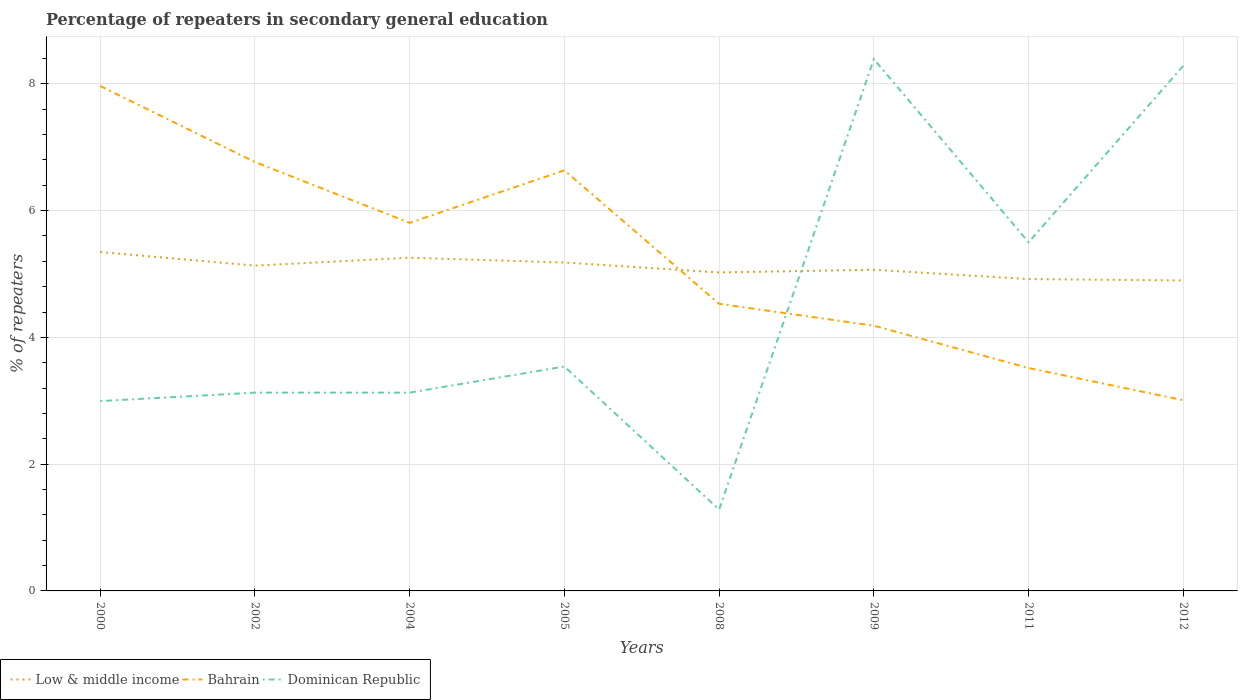Does the line corresponding to Dominican Republic intersect with the line corresponding to Low & middle income?
Offer a terse response. Yes. Across all years, what is the maximum percentage of repeaters in secondary general education in Dominican Republic?
Your answer should be compact. 1.28. In which year was the percentage of repeaters in secondary general education in Dominican Republic maximum?
Ensure brevity in your answer.  2008. What is the total percentage of repeaters in secondary general education in Low & middle income in the graph?
Your answer should be very brief. 0.21. What is the difference between the highest and the second highest percentage of repeaters in secondary general education in Dominican Republic?
Provide a short and direct response. 7.11. How many lines are there?
Make the answer very short. 3. How many years are there in the graph?
Provide a succinct answer. 8. What is the difference between two consecutive major ticks on the Y-axis?
Offer a very short reply. 2. Does the graph contain any zero values?
Offer a very short reply. No. Where does the legend appear in the graph?
Offer a very short reply. Bottom left. How many legend labels are there?
Your answer should be very brief. 3. How are the legend labels stacked?
Offer a terse response. Horizontal. What is the title of the graph?
Offer a very short reply. Percentage of repeaters in secondary general education. Does "Bolivia" appear as one of the legend labels in the graph?
Ensure brevity in your answer.  No. What is the label or title of the Y-axis?
Make the answer very short. % of repeaters. What is the % of repeaters of Low & middle income in 2000?
Offer a terse response. 5.35. What is the % of repeaters in Bahrain in 2000?
Your response must be concise. 7.97. What is the % of repeaters in Dominican Republic in 2000?
Offer a very short reply. 2.99. What is the % of repeaters of Low & middle income in 2002?
Ensure brevity in your answer.  5.13. What is the % of repeaters of Bahrain in 2002?
Offer a very short reply. 6.77. What is the % of repeaters of Dominican Republic in 2002?
Keep it short and to the point. 3.13. What is the % of repeaters of Low & middle income in 2004?
Ensure brevity in your answer.  5.26. What is the % of repeaters in Bahrain in 2004?
Keep it short and to the point. 5.81. What is the % of repeaters of Dominican Republic in 2004?
Offer a terse response. 3.13. What is the % of repeaters of Low & middle income in 2005?
Your answer should be compact. 5.18. What is the % of repeaters of Bahrain in 2005?
Your answer should be very brief. 6.64. What is the % of repeaters in Dominican Republic in 2005?
Ensure brevity in your answer.  3.54. What is the % of repeaters of Low & middle income in 2008?
Your response must be concise. 5.02. What is the % of repeaters in Bahrain in 2008?
Give a very brief answer. 4.53. What is the % of repeaters of Dominican Republic in 2008?
Offer a terse response. 1.28. What is the % of repeaters of Low & middle income in 2009?
Ensure brevity in your answer.  5.07. What is the % of repeaters in Bahrain in 2009?
Make the answer very short. 4.18. What is the % of repeaters of Dominican Republic in 2009?
Offer a terse response. 8.39. What is the % of repeaters of Low & middle income in 2011?
Offer a very short reply. 4.92. What is the % of repeaters in Bahrain in 2011?
Keep it short and to the point. 3.52. What is the % of repeaters of Dominican Republic in 2011?
Make the answer very short. 5.5. What is the % of repeaters in Low & middle income in 2012?
Make the answer very short. 4.9. What is the % of repeaters of Bahrain in 2012?
Your answer should be compact. 3.01. What is the % of repeaters in Dominican Republic in 2012?
Your response must be concise. 8.29. Across all years, what is the maximum % of repeaters of Low & middle income?
Keep it short and to the point. 5.35. Across all years, what is the maximum % of repeaters in Bahrain?
Provide a succinct answer. 7.97. Across all years, what is the maximum % of repeaters in Dominican Republic?
Provide a succinct answer. 8.39. Across all years, what is the minimum % of repeaters of Low & middle income?
Your answer should be very brief. 4.9. Across all years, what is the minimum % of repeaters of Bahrain?
Keep it short and to the point. 3.01. Across all years, what is the minimum % of repeaters of Dominican Republic?
Ensure brevity in your answer.  1.28. What is the total % of repeaters in Low & middle income in the graph?
Offer a terse response. 40.83. What is the total % of repeaters of Bahrain in the graph?
Keep it short and to the point. 42.42. What is the total % of repeaters in Dominican Republic in the graph?
Provide a succinct answer. 36.25. What is the difference between the % of repeaters of Low & middle income in 2000 and that in 2002?
Your answer should be compact. 0.21. What is the difference between the % of repeaters in Bahrain in 2000 and that in 2002?
Offer a very short reply. 1.2. What is the difference between the % of repeaters in Dominican Republic in 2000 and that in 2002?
Your answer should be compact. -0.13. What is the difference between the % of repeaters of Low & middle income in 2000 and that in 2004?
Make the answer very short. 0.09. What is the difference between the % of repeaters in Bahrain in 2000 and that in 2004?
Provide a succinct answer. 2.16. What is the difference between the % of repeaters in Dominican Republic in 2000 and that in 2004?
Keep it short and to the point. -0.13. What is the difference between the % of repeaters of Low & middle income in 2000 and that in 2005?
Your response must be concise. 0.17. What is the difference between the % of repeaters in Bahrain in 2000 and that in 2005?
Keep it short and to the point. 1.33. What is the difference between the % of repeaters in Dominican Republic in 2000 and that in 2005?
Offer a terse response. -0.55. What is the difference between the % of repeaters in Low & middle income in 2000 and that in 2008?
Your answer should be compact. 0.32. What is the difference between the % of repeaters of Bahrain in 2000 and that in 2008?
Your answer should be compact. 3.44. What is the difference between the % of repeaters in Dominican Republic in 2000 and that in 2008?
Offer a terse response. 1.71. What is the difference between the % of repeaters in Low & middle income in 2000 and that in 2009?
Your answer should be compact. 0.28. What is the difference between the % of repeaters in Bahrain in 2000 and that in 2009?
Your answer should be compact. 3.78. What is the difference between the % of repeaters in Dominican Republic in 2000 and that in 2009?
Give a very brief answer. -5.4. What is the difference between the % of repeaters of Low & middle income in 2000 and that in 2011?
Provide a succinct answer. 0.43. What is the difference between the % of repeaters in Bahrain in 2000 and that in 2011?
Give a very brief answer. 4.45. What is the difference between the % of repeaters in Dominican Republic in 2000 and that in 2011?
Your answer should be very brief. -2.51. What is the difference between the % of repeaters of Low & middle income in 2000 and that in 2012?
Keep it short and to the point. 0.45. What is the difference between the % of repeaters in Bahrain in 2000 and that in 2012?
Keep it short and to the point. 4.96. What is the difference between the % of repeaters of Dominican Republic in 2000 and that in 2012?
Make the answer very short. -5.29. What is the difference between the % of repeaters of Low & middle income in 2002 and that in 2004?
Offer a terse response. -0.12. What is the difference between the % of repeaters in Bahrain in 2002 and that in 2004?
Make the answer very short. 0.96. What is the difference between the % of repeaters in Low & middle income in 2002 and that in 2005?
Offer a terse response. -0.05. What is the difference between the % of repeaters of Bahrain in 2002 and that in 2005?
Your answer should be compact. 0.13. What is the difference between the % of repeaters of Dominican Republic in 2002 and that in 2005?
Provide a short and direct response. -0.41. What is the difference between the % of repeaters in Low & middle income in 2002 and that in 2008?
Your answer should be compact. 0.11. What is the difference between the % of repeaters of Bahrain in 2002 and that in 2008?
Offer a very short reply. 2.24. What is the difference between the % of repeaters of Dominican Republic in 2002 and that in 2008?
Provide a short and direct response. 1.85. What is the difference between the % of repeaters in Low & middle income in 2002 and that in 2009?
Your answer should be compact. 0.07. What is the difference between the % of repeaters of Bahrain in 2002 and that in 2009?
Give a very brief answer. 2.58. What is the difference between the % of repeaters of Dominican Republic in 2002 and that in 2009?
Give a very brief answer. -5.26. What is the difference between the % of repeaters in Low & middle income in 2002 and that in 2011?
Make the answer very short. 0.21. What is the difference between the % of repeaters of Dominican Republic in 2002 and that in 2011?
Your answer should be compact. -2.37. What is the difference between the % of repeaters of Low & middle income in 2002 and that in 2012?
Your answer should be very brief. 0.23. What is the difference between the % of repeaters in Bahrain in 2002 and that in 2012?
Offer a terse response. 3.76. What is the difference between the % of repeaters in Dominican Republic in 2002 and that in 2012?
Offer a very short reply. -5.16. What is the difference between the % of repeaters in Low & middle income in 2004 and that in 2005?
Offer a very short reply. 0.08. What is the difference between the % of repeaters in Bahrain in 2004 and that in 2005?
Your answer should be very brief. -0.83. What is the difference between the % of repeaters in Dominican Republic in 2004 and that in 2005?
Keep it short and to the point. -0.41. What is the difference between the % of repeaters in Low & middle income in 2004 and that in 2008?
Your answer should be very brief. 0.23. What is the difference between the % of repeaters of Bahrain in 2004 and that in 2008?
Your response must be concise. 1.28. What is the difference between the % of repeaters of Dominican Republic in 2004 and that in 2008?
Make the answer very short. 1.85. What is the difference between the % of repeaters in Low & middle income in 2004 and that in 2009?
Provide a short and direct response. 0.19. What is the difference between the % of repeaters in Bahrain in 2004 and that in 2009?
Ensure brevity in your answer.  1.62. What is the difference between the % of repeaters in Dominican Republic in 2004 and that in 2009?
Your answer should be very brief. -5.26. What is the difference between the % of repeaters of Low & middle income in 2004 and that in 2011?
Your answer should be very brief. 0.34. What is the difference between the % of repeaters in Bahrain in 2004 and that in 2011?
Make the answer very short. 2.29. What is the difference between the % of repeaters of Dominican Republic in 2004 and that in 2011?
Keep it short and to the point. -2.37. What is the difference between the % of repeaters in Low & middle income in 2004 and that in 2012?
Give a very brief answer. 0.36. What is the difference between the % of repeaters in Bahrain in 2004 and that in 2012?
Give a very brief answer. 2.8. What is the difference between the % of repeaters in Dominican Republic in 2004 and that in 2012?
Your response must be concise. -5.16. What is the difference between the % of repeaters of Low & middle income in 2005 and that in 2008?
Ensure brevity in your answer.  0.16. What is the difference between the % of repeaters in Bahrain in 2005 and that in 2008?
Your answer should be compact. 2.11. What is the difference between the % of repeaters in Dominican Republic in 2005 and that in 2008?
Provide a succinct answer. 2.26. What is the difference between the % of repeaters in Low & middle income in 2005 and that in 2009?
Your answer should be compact. 0.11. What is the difference between the % of repeaters of Bahrain in 2005 and that in 2009?
Provide a short and direct response. 2.45. What is the difference between the % of repeaters of Dominican Republic in 2005 and that in 2009?
Give a very brief answer. -4.85. What is the difference between the % of repeaters in Low & middle income in 2005 and that in 2011?
Provide a short and direct response. 0.26. What is the difference between the % of repeaters in Bahrain in 2005 and that in 2011?
Make the answer very short. 3.12. What is the difference between the % of repeaters of Dominican Republic in 2005 and that in 2011?
Your answer should be compact. -1.96. What is the difference between the % of repeaters in Low & middle income in 2005 and that in 2012?
Provide a succinct answer. 0.28. What is the difference between the % of repeaters of Bahrain in 2005 and that in 2012?
Keep it short and to the point. 3.63. What is the difference between the % of repeaters of Dominican Republic in 2005 and that in 2012?
Give a very brief answer. -4.75. What is the difference between the % of repeaters of Low & middle income in 2008 and that in 2009?
Your answer should be very brief. -0.04. What is the difference between the % of repeaters of Bahrain in 2008 and that in 2009?
Your response must be concise. 0.35. What is the difference between the % of repeaters of Dominican Republic in 2008 and that in 2009?
Your response must be concise. -7.11. What is the difference between the % of repeaters of Low & middle income in 2008 and that in 2011?
Offer a very short reply. 0.11. What is the difference between the % of repeaters in Bahrain in 2008 and that in 2011?
Provide a short and direct response. 1.01. What is the difference between the % of repeaters of Dominican Republic in 2008 and that in 2011?
Provide a short and direct response. -4.22. What is the difference between the % of repeaters of Low & middle income in 2008 and that in 2012?
Your answer should be compact. 0.13. What is the difference between the % of repeaters in Bahrain in 2008 and that in 2012?
Provide a short and direct response. 1.52. What is the difference between the % of repeaters in Dominican Republic in 2008 and that in 2012?
Offer a very short reply. -7. What is the difference between the % of repeaters of Low & middle income in 2009 and that in 2011?
Provide a succinct answer. 0.15. What is the difference between the % of repeaters in Bahrain in 2009 and that in 2011?
Give a very brief answer. 0.67. What is the difference between the % of repeaters of Dominican Republic in 2009 and that in 2011?
Keep it short and to the point. 2.89. What is the difference between the % of repeaters of Low & middle income in 2009 and that in 2012?
Provide a short and direct response. 0.17. What is the difference between the % of repeaters in Bahrain in 2009 and that in 2012?
Provide a succinct answer. 1.18. What is the difference between the % of repeaters of Dominican Republic in 2009 and that in 2012?
Offer a very short reply. 0.1. What is the difference between the % of repeaters in Low & middle income in 2011 and that in 2012?
Provide a succinct answer. 0.02. What is the difference between the % of repeaters of Bahrain in 2011 and that in 2012?
Your response must be concise. 0.51. What is the difference between the % of repeaters in Dominican Republic in 2011 and that in 2012?
Your response must be concise. -2.79. What is the difference between the % of repeaters in Low & middle income in 2000 and the % of repeaters in Bahrain in 2002?
Provide a succinct answer. -1.42. What is the difference between the % of repeaters in Low & middle income in 2000 and the % of repeaters in Dominican Republic in 2002?
Keep it short and to the point. 2.22. What is the difference between the % of repeaters in Bahrain in 2000 and the % of repeaters in Dominican Republic in 2002?
Give a very brief answer. 4.84. What is the difference between the % of repeaters in Low & middle income in 2000 and the % of repeaters in Bahrain in 2004?
Keep it short and to the point. -0.46. What is the difference between the % of repeaters of Low & middle income in 2000 and the % of repeaters of Dominican Republic in 2004?
Your answer should be very brief. 2.22. What is the difference between the % of repeaters of Bahrain in 2000 and the % of repeaters of Dominican Republic in 2004?
Provide a succinct answer. 4.84. What is the difference between the % of repeaters in Low & middle income in 2000 and the % of repeaters in Bahrain in 2005?
Ensure brevity in your answer.  -1.29. What is the difference between the % of repeaters of Low & middle income in 2000 and the % of repeaters of Dominican Republic in 2005?
Provide a short and direct response. 1.81. What is the difference between the % of repeaters in Bahrain in 2000 and the % of repeaters in Dominican Republic in 2005?
Your answer should be very brief. 4.43. What is the difference between the % of repeaters of Low & middle income in 2000 and the % of repeaters of Bahrain in 2008?
Your answer should be very brief. 0.82. What is the difference between the % of repeaters of Low & middle income in 2000 and the % of repeaters of Dominican Republic in 2008?
Ensure brevity in your answer.  4.06. What is the difference between the % of repeaters of Bahrain in 2000 and the % of repeaters of Dominican Republic in 2008?
Provide a succinct answer. 6.68. What is the difference between the % of repeaters of Low & middle income in 2000 and the % of repeaters of Bahrain in 2009?
Offer a very short reply. 1.16. What is the difference between the % of repeaters in Low & middle income in 2000 and the % of repeaters in Dominican Republic in 2009?
Your answer should be very brief. -3.04. What is the difference between the % of repeaters of Bahrain in 2000 and the % of repeaters of Dominican Republic in 2009?
Your response must be concise. -0.42. What is the difference between the % of repeaters in Low & middle income in 2000 and the % of repeaters in Bahrain in 2011?
Your response must be concise. 1.83. What is the difference between the % of repeaters in Low & middle income in 2000 and the % of repeaters in Dominican Republic in 2011?
Your response must be concise. -0.15. What is the difference between the % of repeaters in Bahrain in 2000 and the % of repeaters in Dominican Republic in 2011?
Your response must be concise. 2.47. What is the difference between the % of repeaters in Low & middle income in 2000 and the % of repeaters in Bahrain in 2012?
Make the answer very short. 2.34. What is the difference between the % of repeaters in Low & middle income in 2000 and the % of repeaters in Dominican Republic in 2012?
Offer a very short reply. -2.94. What is the difference between the % of repeaters in Bahrain in 2000 and the % of repeaters in Dominican Republic in 2012?
Give a very brief answer. -0.32. What is the difference between the % of repeaters in Low & middle income in 2002 and the % of repeaters in Bahrain in 2004?
Make the answer very short. -0.67. What is the difference between the % of repeaters of Low & middle income in 2002 and the % of repeaters of Dominican Republic in 2004?
Ensure brevity in your answer.  2. What is the difference between the % of repeaters of Bahrain in 2002 and the % of repeaters of Dominican Republic in 2004?
Make the answer very short. 3.64. What is the difference between the % of repeaters in Low & middle income in 2002 and the % of repeaters in Bahrain in 2005?
Provide a short and direct response. -1.5. What is the difference between the % of repeaters of Low & middle income in 2002 and the % of repeaters of Dominican Republic in 2005?
Keep it short and to the point. 1.59. What is the difference between the % of repeaters in Bahrain in 2002 and the % of repeaters in Dominican Republic in 2005?
Make the answer very short. 3.23. What is the difference between the % of repeaters in Low & middle income in 2002 and the % of repeaters in Bahrain in 2008?
Your answer should be very brief. 0.6. What is the difference between the % of repeaters of Low & middle income in 2002 and the % of repeaters of Dominican Republic in 2008?
Your answer should be very brief. 3.85. What is the difference between the % of repeaters of Bahrain in 2002 and the % of repeaters of Dominican Republic in 2008?
Your response must be concise. 5.48. What is the difference between the % of repeaters in Low & middle income in 2002 and the % of repeaters in Bahrain in 2009?
Ensure brevity in your answer.  0.95. What is the difference between the % of repeaters in Low & middle income in 2002 and the % of repeaters in Dominican Republic in 2009?
Give a very brief answer. -3.26. What is the difference between the % of repeaters in Bahrain in 2002 and the % of repeaters in Dominican Republic in 2009?
Your answer should be very brief. -1.62. What is the difference between the % of repeaters of Low & middle income in 2002 and the % of repeaters of Bahrain in 2011?
Your answer should be very brief. 1.62. What is the difference between the % of repeaters of Low & middle income in 2002 and the % of repeaters of Dominican Republic in 2011?
Offer a very short reply. -0.37. What is the difference between the % of repeaters in Bahrain in 2002 and the % of repeaters in Dominican Republic in 2011?
Provide a short and direct response. 1.27. What is the difference between the % of repeaters of Low & middle income in 2002 and the % of repeaters of Bahrain in 2012?
Your answer should be very brief. 2.12. What is the difference between the % of repeaters of Low & middle income in 2002 and the % of repeaters of Dominican Republic in 2012?
Your answer should be very brief. -3.15. What is the difference between the % of repeaters in Bahrain in 2002 and the % of repeaters in Dominican Republic in 2012?
Your answer should be very brief. -1.52. What is the difference between the % of repeaters of Low & middle income in 2004 and the % of repeaters of Bahrain in 2005?
Make the answer very short. -1.38. What is the difference between the % of repeaters in Low & middle income in 2004 and the % of repeaters in Dominican Republic in 2005?
Your answer should be very brief. 1.72. What is the difference between the % of repeaters in Bahrain in 2004 and the % of repeaters in Dominican Republic in 2005?
Your answer should be very brief. 2.27. What is the difference between the % of repeaters of Low & middle income in 2004 and the % of repeaters of Bahrain in 2008?
Give a very brief answer. 0.73. What is the difference between the % of repeaters in Low & middle income in 2004 and the % of repeaters in Dominican Republic in 2008?
Your answer should be very brief. 3.97. What is the difference between the % of repeaters of Bahrain in 2004 and the % of repeaters of Dominican Republic in 2008?
Provide a short and direct response. 4.52. What is the difference between the % of repeaters of Low & middle income in 2004 and the % of repeaters of Bahrain in 2009?
Offer a terse response. 1.07. What is the difference between the % of repeaters of Low & middle income in 2004 and the % of repeaters of Dominican Republic in 2009?
Your answer should be compact. -3.13. What is the difference between the % of repeaters in Bahrain in 2004 and the % of repeaters in Dominican Republic in 2009?
Your answer should be compact. -2.58. What is the difference between the % of repeaters in Low & middle income in 2004 and the % of repeaters in Bahrain in 2011?
Offer a very short reply. 1.74. What is the difference between the % of repeaters of Low & middle income in 2004 and the % of repeaters of Dominican Republic in 2011?
Keep it short and to the point. -0.24. What is the difference between the % of repeaters of Bahrain in 2004 and the % of repeaters of Dominican Republic in 2011?
Keep it short and to the point. 0.31. What is the difference between the % of repeaters in Low & middle income in 2004 and the % of repeaters in Bahrain in 2012?
Offer a very short reply. 2.25. What is the difference between the % of repeaters of Low & middle income in 2004 and the % of repeaters of Dominican Republic in 2012?
Your response must be concise. -3.03. What is the difference between the % of repeaters of Bahrain in 2004 and the % of repeaters of Dominican Republic in 2012?
Make the answer very short. -2.48. What is the difference between the % of repeaters in Low & middle income in 2005 and the % of repeaters in Bahrain in 2008?
Provide a short and direct response. 0.65. What is the difference between the % of repeaters of Low & middle income in 2005 and the % of repeaters of Dominican Republic in 2008?
Provide a short and direct response. 3.9. What is the difference between the % of repeaters of Bahrain in 2005 and the % of repeaters of Dominican Republic in 2008?
Offer a very short reply. 5.35. What is the difference between the % of repeaters of Low & middle income in 2005 and the % of repeaters of Bahrain in 2009?
Ensure brevity in your answer.  1. What is the difference between the % of repeaters of Low & middle income in 2005 and the % of repeaters of Dominican Republic in 2009?
Give a very brief answer. -3.21. What is the difference between the % of repeaters of Bahrain in 2005 and the % of repeaters of Dominican Republic in 2009?
Your response must be concise. -1.75. What is the difference between the % of repeaters of Low & middle income in 2005 and the % of repeaters of Bahrain in 2011?
Give a very brief answer. 1.66. What is the difference between the % of repeaters of Low & middle income in 2005 and the % of repeaters of Dominican Republic in 2011?
Ensure brevity in your answer.  -0.32. What is the difference between the % of repeaters in Bahrain in 2005 and the % of repeaters in Dominican Republic in 2011?
Provide a short and direct response. 1.14. What is the difference between the % of repeaters of Low & middle income in 2005 and the % of repeaters of Bahrain in 2012?
Offer a terse response. 2.17. What is the difference between the % of repeaters of Low & middle income in 2005 and the % of repeaters of Dominican Republic in 2012?
Offer a very short reply. -3.1. What is the difference between the % of repeaters of Bahrain in 2005 and the % of repeaters of Dominican Republic in 2012?
Offer a very short reply. -1.65. What is the difference between the % of repeaters in Low & middle income in 2008 and the % of repeaters in Bahrain in 2009?
Make the answer very short. 0.84. What is the difference between the % of repeaters of Low & middle income in 2008 and the % of repeaters of Dominican Republic in 2009?
Offer a terse response. -3.37. What is the difference between the % of repeaters in Bahrain in 2008 and the % of repeaters in Dominican Republic in 2009?
Give a very brief answer. -3.86. What is the difference between the % of repeaters of Low & middle income in 2008 and the % of repeaters of Bahrain in 2011?
Give a very brief answer. 1.51. What is the difference between the % of repeaters of Low & middle income in 2008 and the % of repeaters of Dominican Republic in 2011?
Give a very brief answer. -0.48. What is the difference between the % of repeaters of Bahrain in 2008 and the % of repeaters of Dominican Republic in 2011?
Your answer should be very brief. -0.97. What is the difference between the % of repeaters in Low & middle income in 2008 and the % of repeaters in Bahrain in 2012?
Your answer should be compact. 2.02. What is the difference between the % of repeaters of Low & middle income in 2008 and the % of repeaters of Dominican Republic in 2012?
Give a very brief answer. -3.26. What is the difference between the % of repeaters of Bahrain in 2008 and the % of repeaters of Dominican Republic in 2012?
Provide a short and direct response. -3.76. What is the difference between the % of repeaters in Low & middle income in 2009 and the % of repeaters in Bahrain in 2011?
Give a very brief answer. 1.55. What is the difference between the % of repeaters in Low & middle income in 2009 and the % of repeaters in Dominican Republic in 2011?
Your response must be concise. -0.43. What is the difference between the % of repeaters in Bahrain in 2009 and the % of repeaters in Dominican Republic in 2011?
Make the answer very short. -1.32. What is the difference between the % of repeaters of Low & middle income in 2009 and the % of repeaters of Bahrain in 2012?
Make the answer very short. 2.06. What is the difference between the % of repeaters in Low & middle income in 2009 and the % of repeaters in Dominican Republic in 2012?
Keep it short and to the point. -3.22. What is the difference between the % of repeaters in Bahrain in 2009 and the % of repeaters in Dominican Republic in 2012?
Your answer should be very brief. -4.1. What is the difference between the % of repeaters in Low & middle income in 2011 and the % of repeaters in Bahrain in 2012?
Give a very brief answer. 1.91. What is the difference between the % of repeaters in Low & middle income in 2011 and the % of repeaters in Dominican Republic in 2012?
Give a very brief answer. -3.37. What is the difference between the % of repeaters of Bahrain in 2011 and the % of repeaters of Dominican Republic in 2012?
Your answer should be compact. -4.77. What is the average % of repeaters in Low & middle income per year?
Ensure brevity in your answer.  5.1. What is the average % of repeaters of Bahrain per year?
Keep it short and to the point. 5.3. What is the average % of repeaters in Dominican Republic per year?
Offer a terse response. 4.53. In the year 2000, what is the difference between the % of repeaters of Low & middle income and % of repeaters of Bahrain?
Offer a very short reply. -2.62. In the year 2000, what is the difference between the % of repeaters in Low & middle income and % of repeaters in Dominican Republic?
Offer a very short reply. 2.35. In the year 2000, what is the difference between the % of repeaters in Bahrain and % of repeaters in Dominican Republic?
Provide a succinct answer. 4.97. In the year 2002, what is the difference between the % of repeaters in Low & middle income and % of repeaters in Bahrain?
Ensure brevity in your answer.  -1.63. In the year 2002, what is the difference between the % of repeaters of Low & middle income and % of repeaters of Dominican Republic?
Your answer should be compact. 2. In the year 2002, what is the difference between the % of repeaters in Bahrain and % of repeaters in Dominican Republic?
Offer a terse response. 3.64. In the year 2004, what is the difference between the % of repeaters in Low & middle income and % of repeaters in Bahrain?
Offer a very short reply. -0.55. In the year 2004, what is the difference between the % of repeaters in Low & middle income and % of repeaters in Dominican Republic?
Give a very brief answer. 2.13. In the year 2004, what is the difference between the % of repeaters in Bahrain and % of repeaters in Dominican Republic?
Offer a very short reply. 2.68. In the year 2005, what is the difference between the % of repeaters in Low & middle income and % of repeaters in Bahrain?
Ensure brevity in your answer.  -1.45. In the year 2005, what is the difference between the % of repeaters of Low & middle income and % of repeaters of Dominican Republic?
Provide a short and direct response. 1.64. In the year 2005, what is the difference between the % of repeaters of Bahrain and % of repeaters of Dominican Republic?
Make the answer very short. 3.1. In the year 2008, what is the difference between the % of repeaters in Low & middle income and % of repeaters in Bahrain?
Make the answer very short. 0.49. In the year 2008, what is the difference between the % of repeaters of Low & middle income and % of repeaters of Dominican Republic?
Provide a succinct answer. 3.74. In the year 2008, what is the difference between the % of repeaters in Bahrain and % of repeaters in Dominican Republic?
Your answer should be compact. 3.25. In the year 2009, what is the difference between the % of repeaters in Low & middle income and % of repeaters in Bahrain?
Your answer should be compact. 0.88. In the year 2009, what is the difference between the % of repeaters in Low & middle income and % of repeaters in Dominican Republic?
Give a very brief answer. -3.32. In the year 2009, what is the difference between the % of repeaters in Bahrain and % of repeaters in Dominican Republic?
Provide a short and direct response. -4.21. In the year 2011, what is the difference between the % of repeaters in Low & middle income and % of repeaters in Bahrain?
Give a very brief answer. 1.4. In the year 2011, what is the difference between the % of repeaters of Low & middle income and % of repeaters of Dominican Republic?
Keep it short and to the point. -0.58. In the year 2011, what is the difference between the % of repeaters in Bahrain and % of repeaters in Dominican Republic?
Provide a short and direct response. -1.98. In the year 2012, what is the difference between the % of repeaters of Low & middle income and % of repeaters of Bahrain?
Provide a succinct answer. 1.89. In the year 2012, what is the difference between the % of repeaters in Low & middle income and % of repeaters in Dominican Republic?
Your answer should be very brief. -3.39. In the year 2012, what is the difference between the % of repeaters of Bahrain and % of repeaters of Dominican Republic?
Offer a very short reply. -5.28. What is the ratio of the % of repeaters in Low & middle income in 2000 to that in 2002?
Provide a short and direct response. 1.04. What is the ratio of the % of repeaters in Bahrain in 2000 to that in 2002?
Make the answer very short. 1.18. What is the ratio of the % of repeaters of Dominican Republic in 2000 to that in 2002?
Ensure brevity in your answer.  0.96. What is the ratio of the % of repeaters in Low & middle income in 2000 to that in 2004?
Offer a very short reply. 1.02. What is the ratio of the % of repeaters in Bahrain in 2000 to that in 2004?
Your answer should be compact. 1.37. What is the ratio of the % of repeaters in Dominican Republic in 2000 to that in 2004?
Provide a short and direct response. 0.96. What is the ratio of the % of repeaters in Low & middle income in 2000 to that in 2005?
Give a very brief answer. 1.03. What is the ratio of the % of repeaters in Bahrain in 2000 to that in 2005?
Offer a very short reply. 1.2. What is the ratio of the % of repeaters in Dominican Republic in 2000 to that in 2005?
Keep it short and to the point. 0.85. What is the ratio of the % of repeaters of Low & middle income in 2000 to that in 2008?
Ensure brevity in your answer.  1.06. What is the ratio of the % of repeaters of Bahrain in 2000 to that in 2008?
Ensure brevity in your answer.  1.76. What is the ratio of the % of repeaters in Dominican Republic in 2000 to that in 2008?
Ensure brevity in your answer.  2.33. What is the ratio of the % of repeaters in Low & middle income in 2000 to that in 2009?
Provide a succinct answer. 1.06. What is the ratio of the % of repeaters of Bahrain in 2000 to that in 2009?
Give a very brief answer. 1.9. What is the ratio of the % of repeaters of Dominican Republic in 2000 to that in 2009?
Give a very brief answer. 0.36. What is the ratio of the % of repeaters in Low & middle income in 2000 to that in 2011?
Your answer should be very brief. 1.09. What is the ratio of the % of repeaters of Bahrain in 2000 to that in 2011?
Ensure brevity in your answer.  2.27. What is the ratio of the % of repeaters in Dominican Republic in 2000 to that in 2011?
Offer a terse response. 0.54. What is the ratio of the % of repeaters in Low & middle income in 2000 to that in 2012?
Provide a short and direct response. 1.09. What is the ratio of the % of repeaters of Bahrain in 2000 to that in 2012?
Keep it short and to the point. 2.65. What is the ratio of the % of repeaters in Dominican Republic in 2000 to that in 2012?
Ensure brevity in your answer.  0.36. What is the ratio of the % of repeaters of Low & middle income in 2002 to that in 2004?
Your response must be concise. 0.98. What is the ratio of the % of repeaters in Bahrain in 2002 to that in 2004?
Give a very brief answer. 1.17. What is the ratio of the % of repeaters of Dominican Republic in 2002 to that in 2004?
Ensure brevity in your answer.  1. What is the ratio of the % of repeaters in Low & middle income in 2002 to that in 2005?
Your answer should be very brief. 0.99. What is the ratio of the % of repeaters in Bahrain in 2002 to that in 2005?
Offer a very short reply. 1.02. What is the ratio of the % of repeaters in Dominican Republic in 2002 to that in 2005?
Your answer should be compact. 0.88. What is the ratio of the % of repeaters of Low & middle income in 2002 to that in 2008?
Your response must be concise. 1.02. What is the ratio of the % of repeaters of Bahrain in 2002 to that in 2008?
Offer a very short reply. 1.49. What is the ratio of the % of repeaters of Dominican Republic in 2002 to that in 2008?
Give a very brief answer. 2.44. What is the ratio of the % of repeaters in Low & middle income in 2002 to that in 2009?
Your answer should be compact. 1.01. What is the ratio of the % of repeaters of Bahrain in 2002 to that in 2009?
Provide a short and direct response. 1.62. What is the ratio of the % of repeaters of Dominican Republic in 2002 to that in 2009?
Your answer should be very brief. 0.37. What is the ratio of the % of repeaters of Low & middle income in 2002 to that in 2011?
Offer a terse response. 1.04. What is the ratio of the % of repeaters of Bahrain in 2002 to that in 2011?
Provide a short and direct response. 1.92. What is the ratio of the % of repeaters in Dominican Republic in 2002 to that in 2011?
Provide a succinct answer. 0.57. What is the ratio of the % of repeaters of Low & middle income in 2002 to that in 2012?
Your answer should be very brief. 1.05. What is the ratio of the % of repeaters of Bahrain in 2002 to that in 2012?
Make the answer very short. 2.25. What is the ratio of the % of repeaters of Dominican Republic in 2002 to that in 2012?
Your response must be concise. 0.38. What is the ratio of the % of repeaters in Low & middle income in 2004 to that in 2005?
Your answer should be very brief. 1.01. What is the ratio of the % of repeaters of Bahrain in 2004 to that in 2005?
Give a very brief answer. 0.88. What is the ratio of the % of repeaters of Dominican Republic in 2004 to that in 2005?
Offer a terse response. 0.88. What is the ratio of the % of repeaters in Low & middle income in 2004 to that in 2008?
Keep it short and to the point. 1.05. What is the ratio of the % of repeaters of Bahrain in 2004 to that in 2008?
Provide a short and direct response. 1.28. What is the ratio of the % of repeaters in Dominican Republic in 2004 to that in 2008?
Ensure brevity in your answer.  2.44. What is the ratio of the % of repeaters in Low & middle income in 2004 to that in 2009?
Keep it short and to the point. 1.04. What is the ratio of the % of repeaters of Bahrain in 2004 to that in 2009?
Your response must be concise. 1.39. What is the ratio of the % of repeaters of Dominican Republic in 2004 to that in 2009?
Make the answer very short. 0.37. What is the ratio of the % of repeaters in Low & middle income in 2004 to that in 2011?
Keep it short and to the point. 1.07. What is the ratio of the % of repeaters in Bahrain in 2004 to that in 2011?
Your response must be concise. 1.65. What is the ratio of the % of repeaters of Dominican Republic in 2004 to that in 2011?
Provide a succinct answer. 0.57. What is the ratio of the % of repeaters of Low & middle income in 2004 to that in 2012?
Make the answer very short. 1.07. What is the ratio of the % of repeaters in Bahrain in 2004 to that in 2012?
Your response must be concise. 1.93. What is the ratio of the % of repeaters of Dominican Republic in 2004 to that in 2012?
Provide a succinct answer. 0.38. What is the ratio of the % of repeaters of Low & middle income in 2005 to that in 2008?
Offer a very short reply. 1.03. What is the ratio of the % of repeaters of Bahrain in 2005 to that in 2008?
Provide a succinct answer. 1.46. What is the ratio of the % of repeaters in Dominican Republic in 2005 to that in 2008?
Provide a succinct answer. 2.76. What is the ratio of the % of repeaters in Low & middle income in 2005 to that in 2009?
Offer a very short reply. 1.02. What is the ratio of the % of repeaters of Bahrain in 2005 to that in 2009?
Your response must be concise. 1.59. What is the ratio of the % of repeaters in Dominican Republic in 2005 to that in 2009?
Offer a very short reply. 0.42. What is the ratio of the % of repeaters of Low & middle income in 2005 to that in 2011?
Offer a terse response. 1.05. What is the ratio of the % of repeaters in Bahrain in 2005 to that in 2011?
Make the answer very short. 1.89. What is the ratio of the % of repeaters of Dominican Republic in 2005 to that in 2011?
Your answer should be very brief. 0.64. What is the ratio of the % of repeaters in Low & middle income in 2005 to that in 2012?
Give a very brief answer. 1.06. What is the ratio of the % of repeaters of Bahrain in 2005 to that in 2012?
Offer a terse response. 2.21. What is the ratio of the % of repeaters of Dominican Republic in 2005 to that in 2012?
Keep it short and to the point. 0.43. What is the ratio of the % of repeaters of Low & middle income in 2008 to that in 2009?
Provide a short and direct response. 0.99. What is the ratio of the % of repeaters in Bahrain in 2008 to that in 2009?
Make the answer very short. 1.08. What is the ratio of the % of repeaters in Dominican Republic in 2008 to that in 2009?
Ensure brevity in your answer.  0.15. What is the ratio of the % of repeaters in Low & middle income in 2008 to that in 2011?
Provide a succinct answer. 1.02. What is the ratio of the % of repeaters of Bahrain in 2008 to that in 2011?
Ensure brevity in your answer.  1.29. What is the ratio of the % of repeaters of Dominican Republic in 2008 to that in 2011?
Your answer should be very brief. 0.23. What is the ratio of the % of repeaters of Low & middle income in 2008 to that in 2012?
Make the answer very short. 1.03. What is the ratio of the % of repeaters in Bahrain in 2008 to that in 2012?
Your answer should be compact. 1.51. What is the ratio of the % of repeaters of Dominican Republic in 2008 to that in 2012?
Ensure brevity in your answer.  0.15. What is the ratio of the % of repeaters of Low & middle income in 2009 to that in 2011?
Give a very brief answer. 1.03. What is the ratio of the % of repeaters of Bahrain in 2009 to that in 2011?
Make the answer very short. 1.19. What is the ratio of the % of repeaters of Dominican Republic in 2009 to that in 2011?
Offer a very short reply. 1.53. What is the ratio of the % of repeaters in Low & middle income in 2009 to that in 2012?
Your answer should be compact. 1.03. What is the ratio of the % of repeaters in Bahrain in 2009 to that in 2012?
Provide a succinct answer. 1.39. What is the ratio of the % of repeaters in Dominican Republic in 2009 to that in 2012?
Offer a very short reply. 1.01. What is the ratio of the % of repeaters of Low & middle income in 2011 to that in 2012?
Make the answer very short. 1. What is the ratio of the % of repeaters in Bahrain in 2011 to that in 2012?
Provide a succinct answer. 1.17. What is the ratio of the % of repeaters in Dominican Republic in 2011 to that in 2012?
Provide a short and direct response. 0.66. What is the difference between the highest and the second highest % of repeaters of Low & middle income?
Keep it short and to the point. 0.09. What is the difference between the highest and the second highest % of repeaters of Bahrain?
Provide a succinct answer. 1.2. What is the difference between the highest and the second highest % of repeaters in Dominican Republic?
Ensure brevity in your answer.  0.1. What is the difference between the highest and the lowest % of repeaters of Low & middle income?
Make the answer very short. 0.45. What is the difference between the highest and the lowest % of repeaters in Bahrain?
Your response must be concise. 4.96. What is the difference between the highest and the lowest % of repeaters of Dominican Republic?
Your response must be concise. 7.11. 